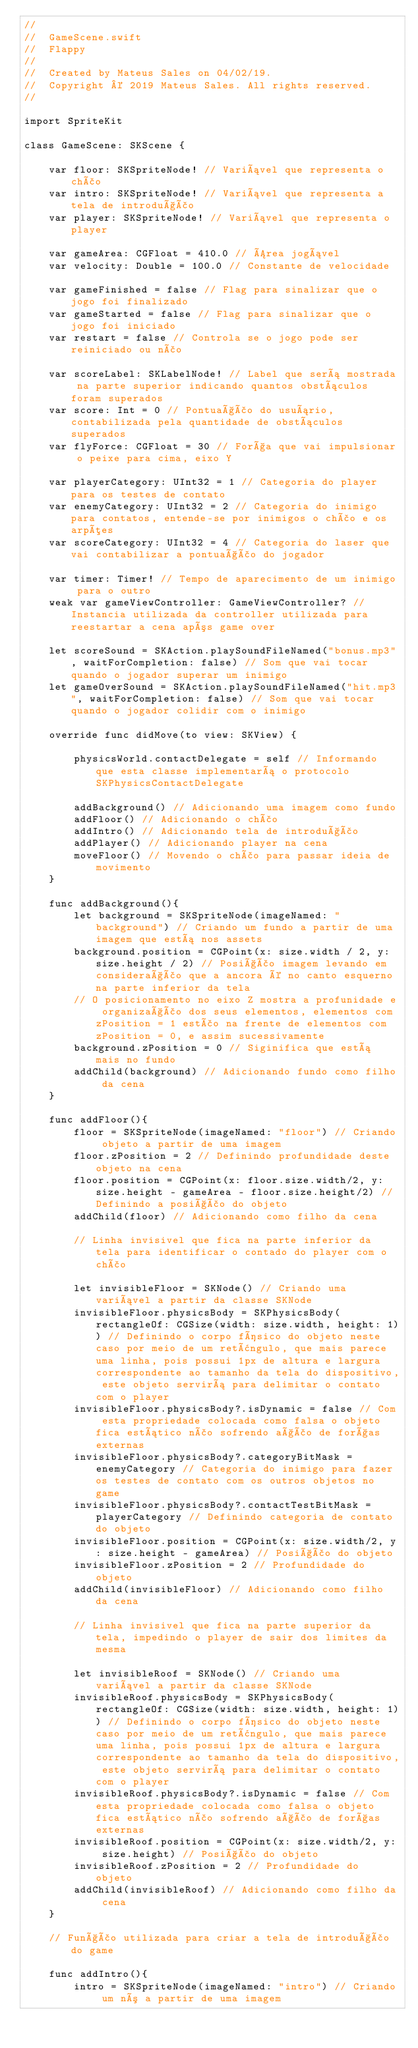<code> <loc_0><loc_0><loc_500><loc_500><_Swift_>//
//  GameScene.swift
//  Flappy
//
//  Created by Mateus Sales on 04/02/19.
//  Copyright © 2019 Mateus Sales. All rights reserved.
//

import SpriteKit

class GameScene: SKScene {
    
    var floor: SKSpriteNode! // Variável que representa o chão
    var intro: SKSpriteNode! // Variável que representa a tela de introdução
    var player: SKSpriteNode! // Variável que representa o player
    
    var gameArea: CGFloat = 410.0 // Área jogável
    var velocity: Double = 100.0 // Constante de velocidade
    
    var gameFinished = false // Flag para sinalizar que o jogo foi finalizado
    var gameStarted = false // Flag para sinalizar que o jogo foi iniciado
    var restart = false // Controla se o jogo pode ser reiniciado ou não
    
    var scoreLabel: SKLabelNode! // Label que será mostrada na parte superior indicando quantos obstáculos foram superados
    var score: Int = 0 // Pontuação do usuário, contabilizada pela quantidade de obstáculos superados
    var flyForce: CGFloat = 30 // Força que vai impulsionar o peixe para cima, eixo Y
   
    var playerCategory: UInt32 = 1 // Categoria do player para os testes de contato
    var enemyCategory: UInt32 = 2 // Categoria do inimigo para contatos, entende-se por inimigos o chão e os arpões
    var scoreCategory: UInt32 = 4 // Categoria do laser que vai contabilizar a pontuação do jogador
    
    var timer: Timer! // Tempo de aparecimento de um inimigo para o outro
    weak var gameViewController: GameViewController? // Instancia utilizada da controller utilizada para reestartar a cena após game over
    
    let scoreSound = SKAction.playSoundFileNamed("bonus.mp3", waitForCompletion: false) // Som que vai tocar quando o jogador superar um inimigo
    let gameOverSound = SKAction.playSoundFileNamed("hit.mp3", waitForCompletion: false) // Som que vai tocar quando o jogador colidir com o inimigo
    
    override func didMove(to view: SKView) {
        
        physicsWorld.contactDelegate = self // Informando que esta classe implementará o protocolo SKPhysicsContactDelegate
        
        addBackground() // Adicionando uma imagem como fundo
        addFloor() // Adicionando o chão
        addIntro() // Adicionando tela de introdução
        addPlayer() // Adicionando player na cena
        moveFloor() // Movendo o chão para passar ideia de movimento
    }
    
    func addBackground(){
        let background = SKSpriteNode(imageNamed: "background") // Criando um fundo a partir de uma imagem que está nos assets
        background.position = CGPoint(x: size.width / 2, y: size.height / 2) // Posição imagem levando em consideração que a ancora é no canto esquerno na parte inferior da tela
        // O posicionamento no eixo Z mostra a profunidade e organização dos seus elementos, elementos com zPosition = 1 estão na frente de elementos com zPosition = 0, e assim sucessivamente
        background.zPosition = 0 // Siginifica que está mais no fundo
        addChild(background) // Adicionando fundo como filho da cena
    }
    
    func addFloor(){
        floor = SKSpriteNode(imageNamed: "floor") // Criando objeto a partir de uma imagem
        floor.zPosition = 2 // Definindo profundidade deste objeto na cena
        floor.position = CGPoint(x: floor.size.width/2, y: size.height - gameArea - floor.size.height/2) // Definindo a posição do objeto
        addChild(floor) // Adicionando como filho da cena
        
        // Linha invisivel que fica na parte inferior da tela para identificar o contado do player com o chão
        
        let invisibleFloor = SKNode() // Criando uma variável a partir da classe SKNode
        invisibleFloor.physicsBody = SKPhysicsBody(rectangleOf: CGSize(width: size.width, height: 1)) // Definindo o corpo físico do objeto neste caso por meio de um retângulo, que mais parece uma linha, pois possui 1px de altura e largura correspondente ao tamanho da tela do dispositivo, este objeto servirá para delimitar o contato com o player
        invisibleFloor.physicsBody?.isDynamic = false // Com esta propriedade colocada como falsa o objeto fica estático não sofrendo ação de forças externas
        invisibleFloor.physicsBody?.categoryBitMask = enemyCategory // Categoria do inimigo para fazer os testes de contato com os outros objetos no game
        invisibleFloor.physicsBody?.contactTestBitMask = playerCategory // Definindo categoria de contato do objeto
        invisibleFloor.position = CGPoint(x: size.width/2, y: size.height - gameArea) // Posição do objeto
        invisibleFloor.zPosition = 2 // Profundidade do objeto
        addChild(invisibleFloor) // Adicionando como filho da cena
        
        // Linha invisivel que fica na parte superior da tela, impedindo o player de sair dos limites da mesma
        
        let invisibleRoof = SKNode() // Criando uma variável a partir da classe SKNode
        invisibleRoof.physicsBody = SKPhysicsBody(rectangleOf: CGSize(width: size.width, height: 1)) // Definindo o corpo físico do objeto neste caso por meio de um retângulo, que mais parece uma linha, pois possui 1px de altura e largura correspondente ao tamanho da tela do dispositivo, este objeto servirá para delimitar o contato com o player
        invisibleRoof.physicsBody?.isDynamic = false // Com esta propriedade colocada como falsa o objeto fica estático não sofrendo ação de forças externas
        invisibleRoof.position = CGPoint(x: size.width/2, y: size.height) // Posição do objeto
        invisibleRoof.zPosition = 2 // Profundidade do objeto
        addChild(invisibleRoof) // Adicionando como filho da cena
    }
    
    // Função utilizada para criar a tela de introdução do game
    
    func addIntro(){
        intro = SKSpriteNode(imageNamed: "intro") // Criando um nó a partir de uma imagem</code> 